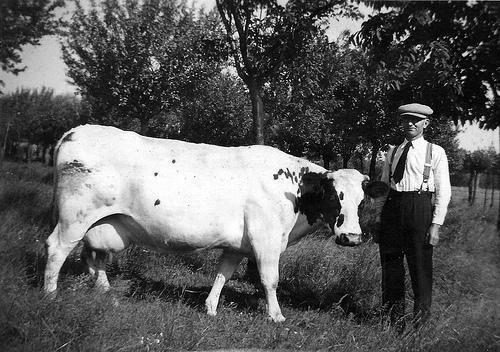How many cows are in the picture?
Give a very brief answer. 1. 